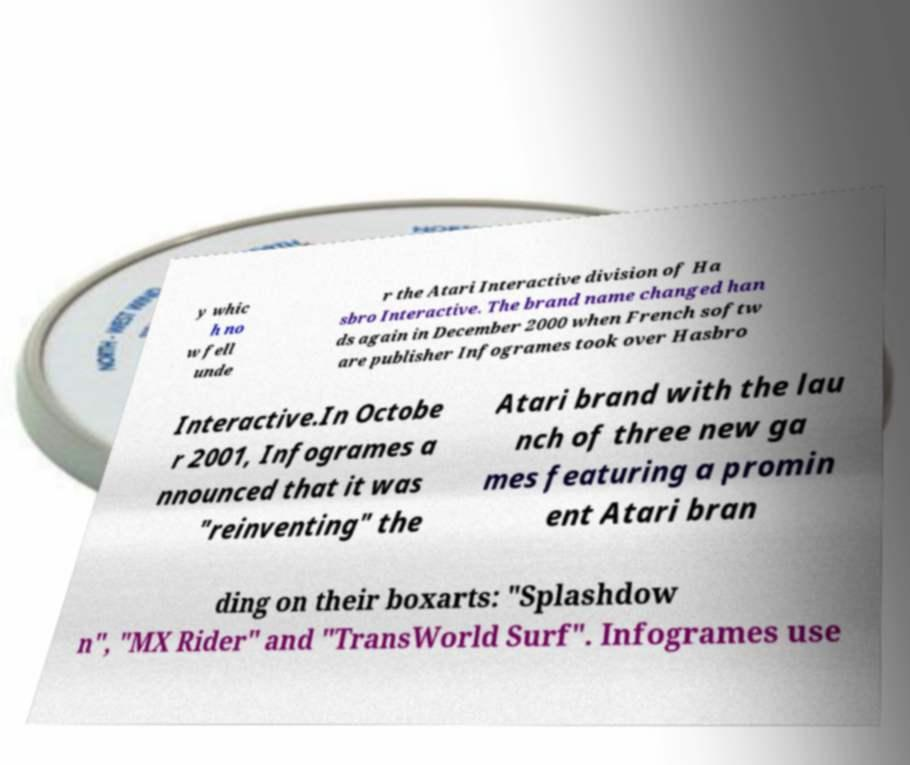Can you accurately transcribe the text from the provided image for me? y whic h no w fell unde r the Atari Interactive division of Ha sbro Interactive. The brand name changed han ds again in December 2000 when French softw are publisher Infogrames took over Hasbro Interactive.In Octobe r 2001, Infogrames a nnounced that it was "reinventing" the Atari brand with the lau nch of three new ga mes featuring a promin ent Atari bran ding on their boxarts: "Splashdow n", "MX Rider" and "TransWorld Surf". Infogrames use 